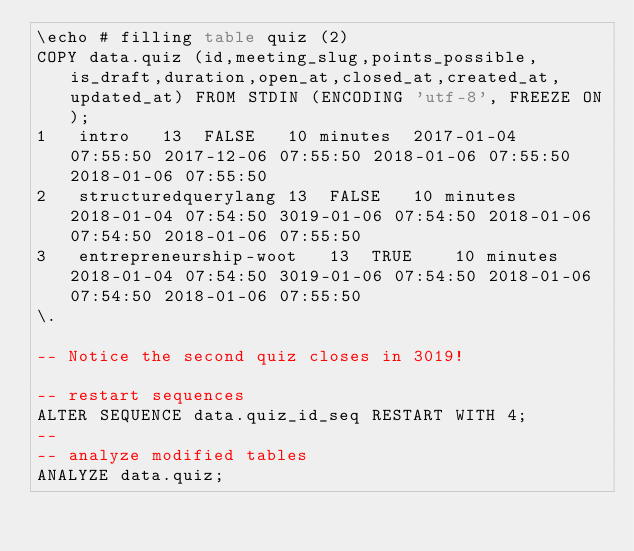Convert code to text. <code><loc_0><loc_0><loc_500><loc_500><_SQL_>\echo # filling table quiz (2)
COPY data.quiz (id,meeting_slug,points_possible,is_draft,duration,open_at,closed_at,created_at,updated_at) FROM STDIN (ENCODING 'utf-8', FREEZE ON);
1	intro	13	FALSE	10 minutes	2017-01-04 07:55:50	2017-12-06 07:55:50	2018-01-06 07:55:50	2018-01-06 07:55:50
2	structuredquerylang	13	FALSE	10 minutes	2018-01-04 07:54:50	3019-01-06 07:54:50	2018-01-06 07:54:50	2018-01-06 07:55:50
3	entrepreneurship-woot	13	TRUE	10 minutes	2018-01-04 07:54:50	3019-01-06 07:54:50	2018-01-06 07:54:50	2018-01-06 07:55:50
\.

-- Notice the second quiz closes in 3019!

-- restart sequences
ALTER SEQUENCE data.quiz_id_seq RESTART WITH 4;
-- 
-- analyze modified tables
ANALYZE data.quiz;
</code> 